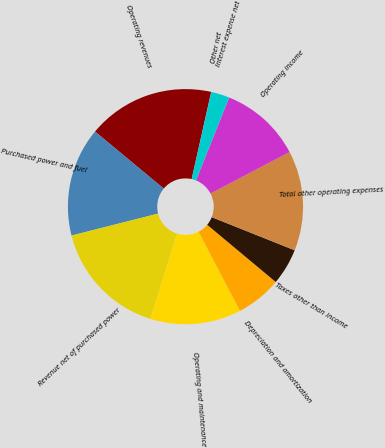<chart> <loc_0><loc_0><loc_500><loc_500><pie_chart><fcel>Operating revenues<fcel>Purchased power and fuel<fcel>Revenue net of purchased power<fcel>Operating and maintenance<fcel>Depreciation and amortization<fcel>Taxes other than income<fcel>Total other operating expenses<fcel>Operating income<fcel>Interest expense net<fcel>Other net<nl><fcel>17.48%<fcel>14.98%<fcel>16.23%<fcel>12.49%<fcel>6.26%<fcel>5.02%<fcel>13.74%<fcel>11.25%<fcel>2.52%<fcel>0.03%<nl></chart> 